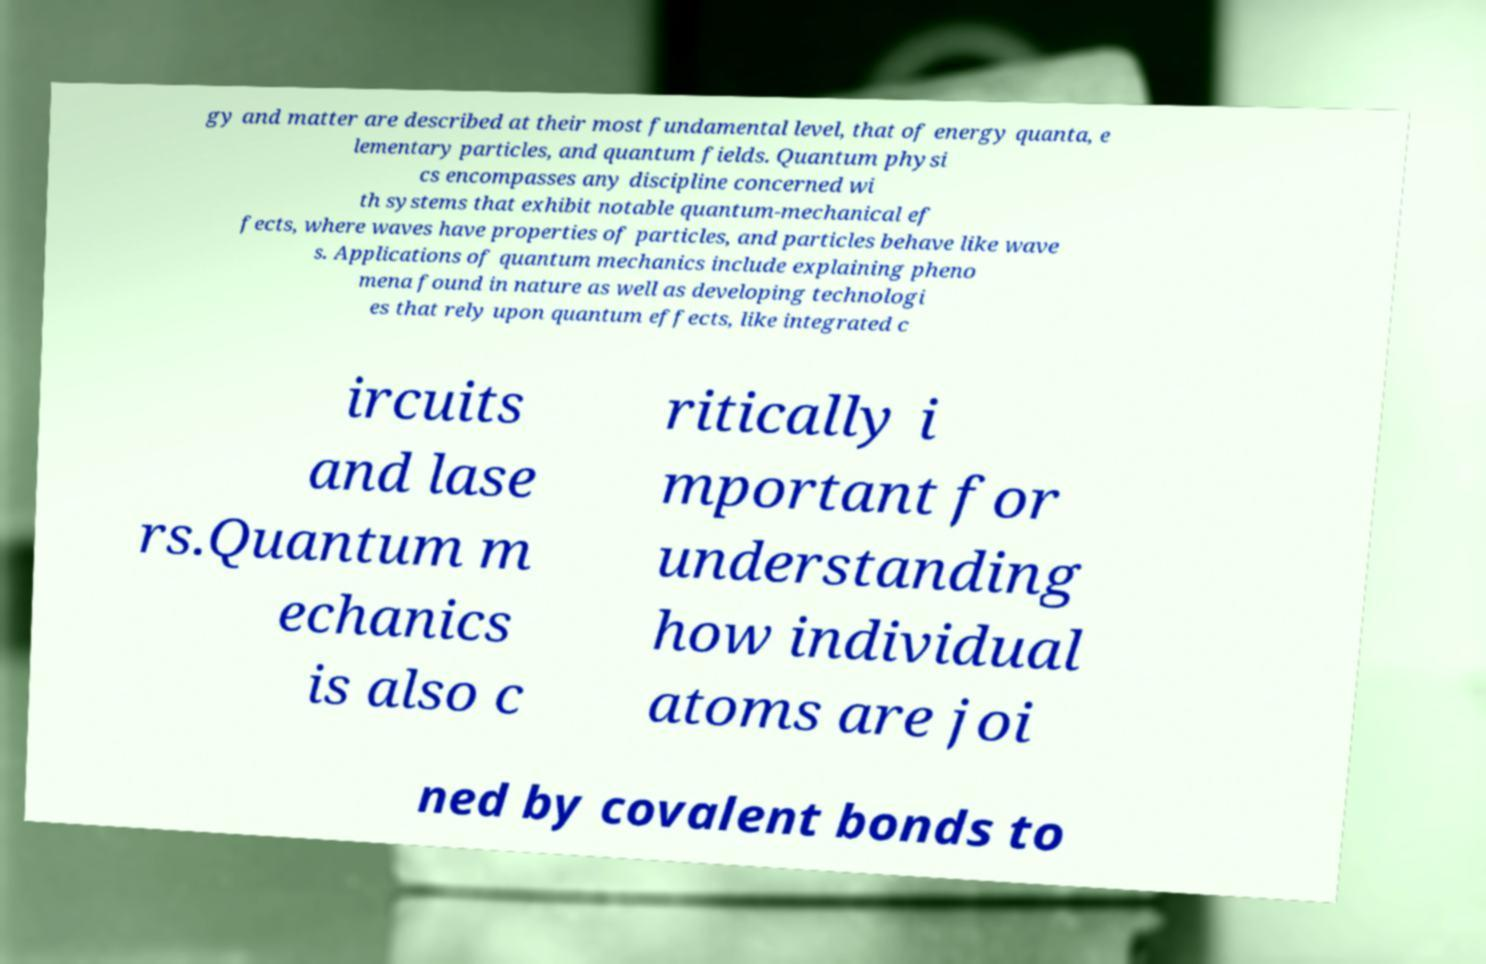Could you extract and type out the text from this image? gy and matter are described at their most fundamental level, that of energy quanta, e lementary particles, and quantum fields. Quantum physi cs encompasses any discipline concerned wi th systems that exhibit notable quantum-mechanical ef fects, where waves have properties of particles, and particles behave like wave s. Applications of quantum mechanics include explaining pheno mena found in nature as well as developing technologi es that rely upon quantum effects, like integrated c ircuits and lase rs.Quantum m echanics is also c ritically i mportant for understanding how individual atoms are joi ned by covalent bonds to 